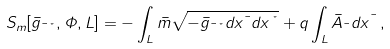Convert formula to latex. <formula><loc_0><loc_0><loc_500><loc_500>S _ { m } [ \bar { g } _ { \mu \nu } , \Phi , L ] = - \int _ { L } \bar { m } \sqrt { - \bar { g } _ { \mu \nu } d x ^ { \mu } d x ^ { \nu } } + q \int _ { L } \bar { A } _ { \mu } d x ^ { \mu } \, ,</formula> 